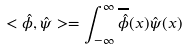<formula> <loc_0><loc_0><loc_500><loc_500>< \hat { \phi } , \hat { \psi } > = \int _ { - \infty } ^ { \infty } \overline { \hat { \phi } } ( x ) \hat { \psi } ( x )</formula> 